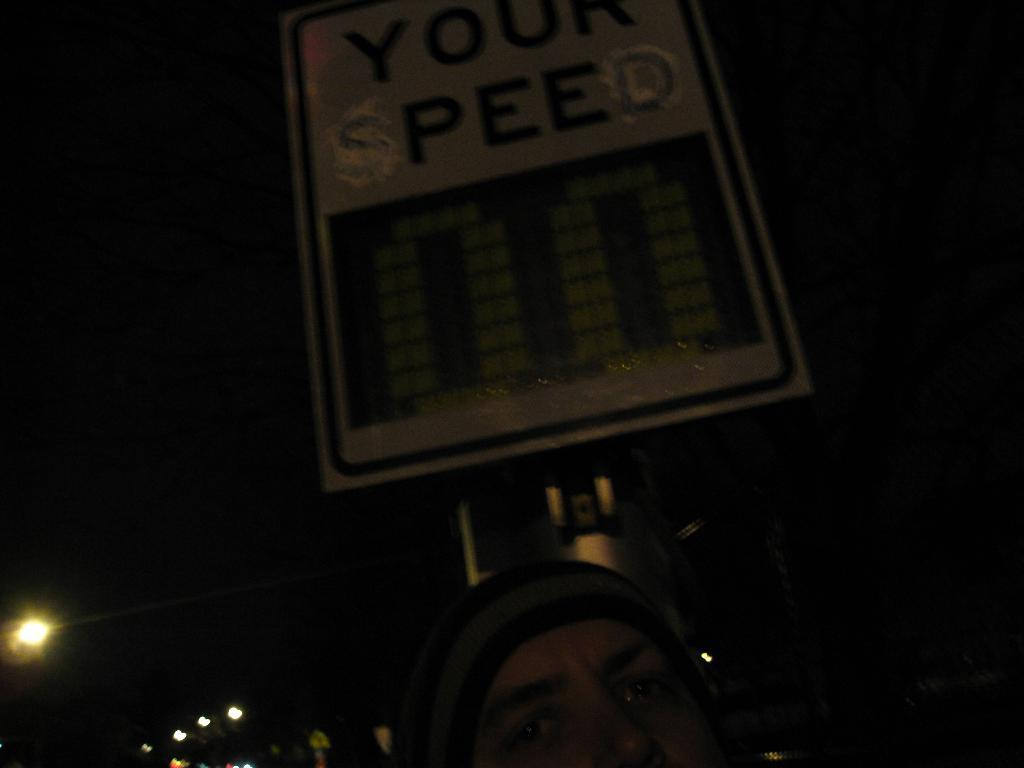What is the main subject of the image? The main subject of the image is a person's head wearing a cap. What else can be seen in the image besides the person's head? There is a pole in the image, and a board is attached to the pole. What is the purpose of the board in the image? The purpose of the board in the image is not clear from the provided facts. What can be seen in the background of the image? There are lights visible in the background of the image, and the sky is dark. What type of grass is being washed by the representative in the image? There is no grass, washing, or representative present in the image. 